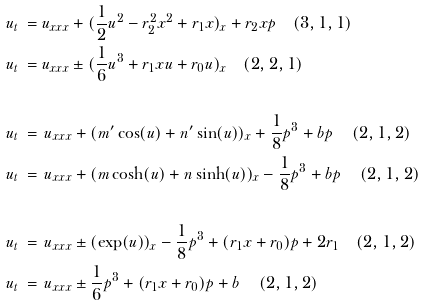<formula> <loc_0><loc_0><loc_500><loc_500>u _ { t } \, & = u _ { x x x } + ( \frac { 1 } { 2 } u ^ { 2 } - r _ { 2 } ^ { 2 } x ^ { 2 } + r _ { 1 } x ) _ { x } + r _ { 2 } x p \quad ( 3 , 1 , 1 ) \\ u _ { t } \, & = u _ { x x x } \pm ( \frac { 1 } { 6 } u ^ { 3 } + r _ { 1 } x u + r _ { 0 } u ) _ { x } \quad ( 2 , 2 , 1 ) \\ & \\ u _ { t } \, & = \, u _ { x x x } + ( m ^ { \prime } \cos ( u ) + n ^ { \prime } \sin ( u ) ) _ { x } + \frac { 1 } { 8 } p ^ { 3 } + b p \quad \, ( 2 , 1 , 2 ) \\ u _ { t } \, & = \, u _ { x x x } + ( m \cosh ( u ) + n \sinh ( u ) ) _ { x } - \frac { 1 } { 8 } p ^ { 3 } + b p \quad \, ( 2 , 1 , 2 ) \\ & \\ u _ { t } \, & = \, u _ { x x x } \pm ( \exp ( u ) ) _ { x } - \frac { 1 } { 8 } p ^ { 3 } + ( r _ { 1 } x + r _ { 0 } ) p + 2 r _ { 1 } \quad ( 2 , 1 , 2 ) \\ u _ { t } \, & = \, u _ { x x x } \pm \frac { 1 } { 6 } p ^ { 3 } + ( r _ { 1 } x + r _ { 0 } ) p + b \quad \, ( 2 , 1 , 2 )</formula> 